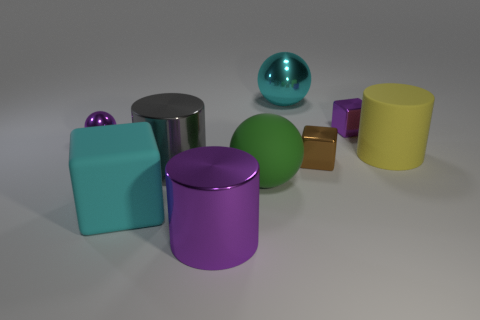Add 1 big gray metallic objects. How many objects exist? 10 Subtract all cylinders. How many objects are left? 6 Subtract 0 red cylinders. How many objects are left? 9 Subtract all big spheres. Subtract all large green balls. How many objects are left? 6 Add 9 large cyan blocks. How many large cyan blocks are left? 10 Add 3 big yellow objects. How many big yellow objects exist? 4 